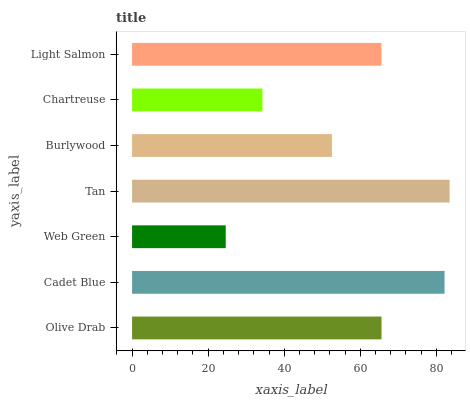Is Web Green the minimum?
Answer yes or no. Yes. Is Tan the maximum?
Answer yes or no. Yes. Is Cadet Blue the minimum?
Answer yes or no. No. Is Cadet Blue the maximum?
Answer yes or no. No. Is Cadet Blue greater than Olive Drab?
Answer yes or no. Yes. Is Olive Drab less than Cadet Blue?
Answer yes or no. Yes. Is Olive Drab greater than Cadet Blue?
Answer yes or no. No. Is Cadet Blue less than Olive Drab?
Answer yes or no. No. Is Light Salmon the high median?
Answer yes or no. Yes. Is Light Salmon the low median?
Answer yes or no. Yes. Is Burlywood the high median?
Answer yes or no. No. Is Web Green the low median?
Answer yes or no. No. 